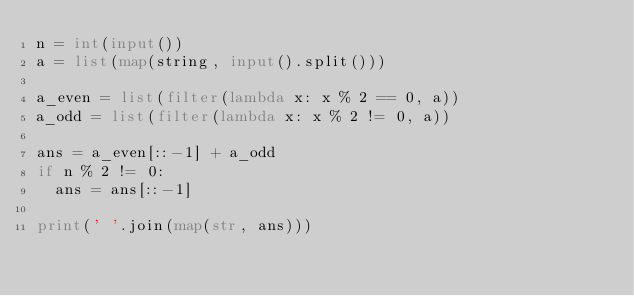<code> <loc_0><loc_0><loc_500><loc_500><_Python_>n = int(input())
a = list(map(string, input().split()))

a_even = list(filter(lambda x: x % 2 == 0, a))
a_odd = list(filter(lambda x: x % 2 != 0, a))

ans = a_even[::-1] + a_odd
if n % 2 != 0:
  ans = ans[::-1]

print(' '.join(map(str, ans)))</code> 